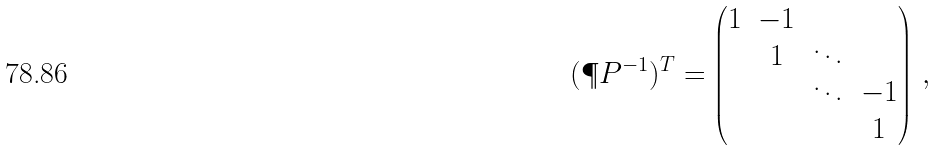<formula> <loc_0><loc_0><loc_500><loc_500>( \P P ^ { - 1 } ) ^ { T } = \begin{pmatrix} 1 & - 1 \\ & 1 & \ddots \\ & & \ddots & - 1 \\ & & & 1 \\ \end{pmatrix} \, ,</formula> 